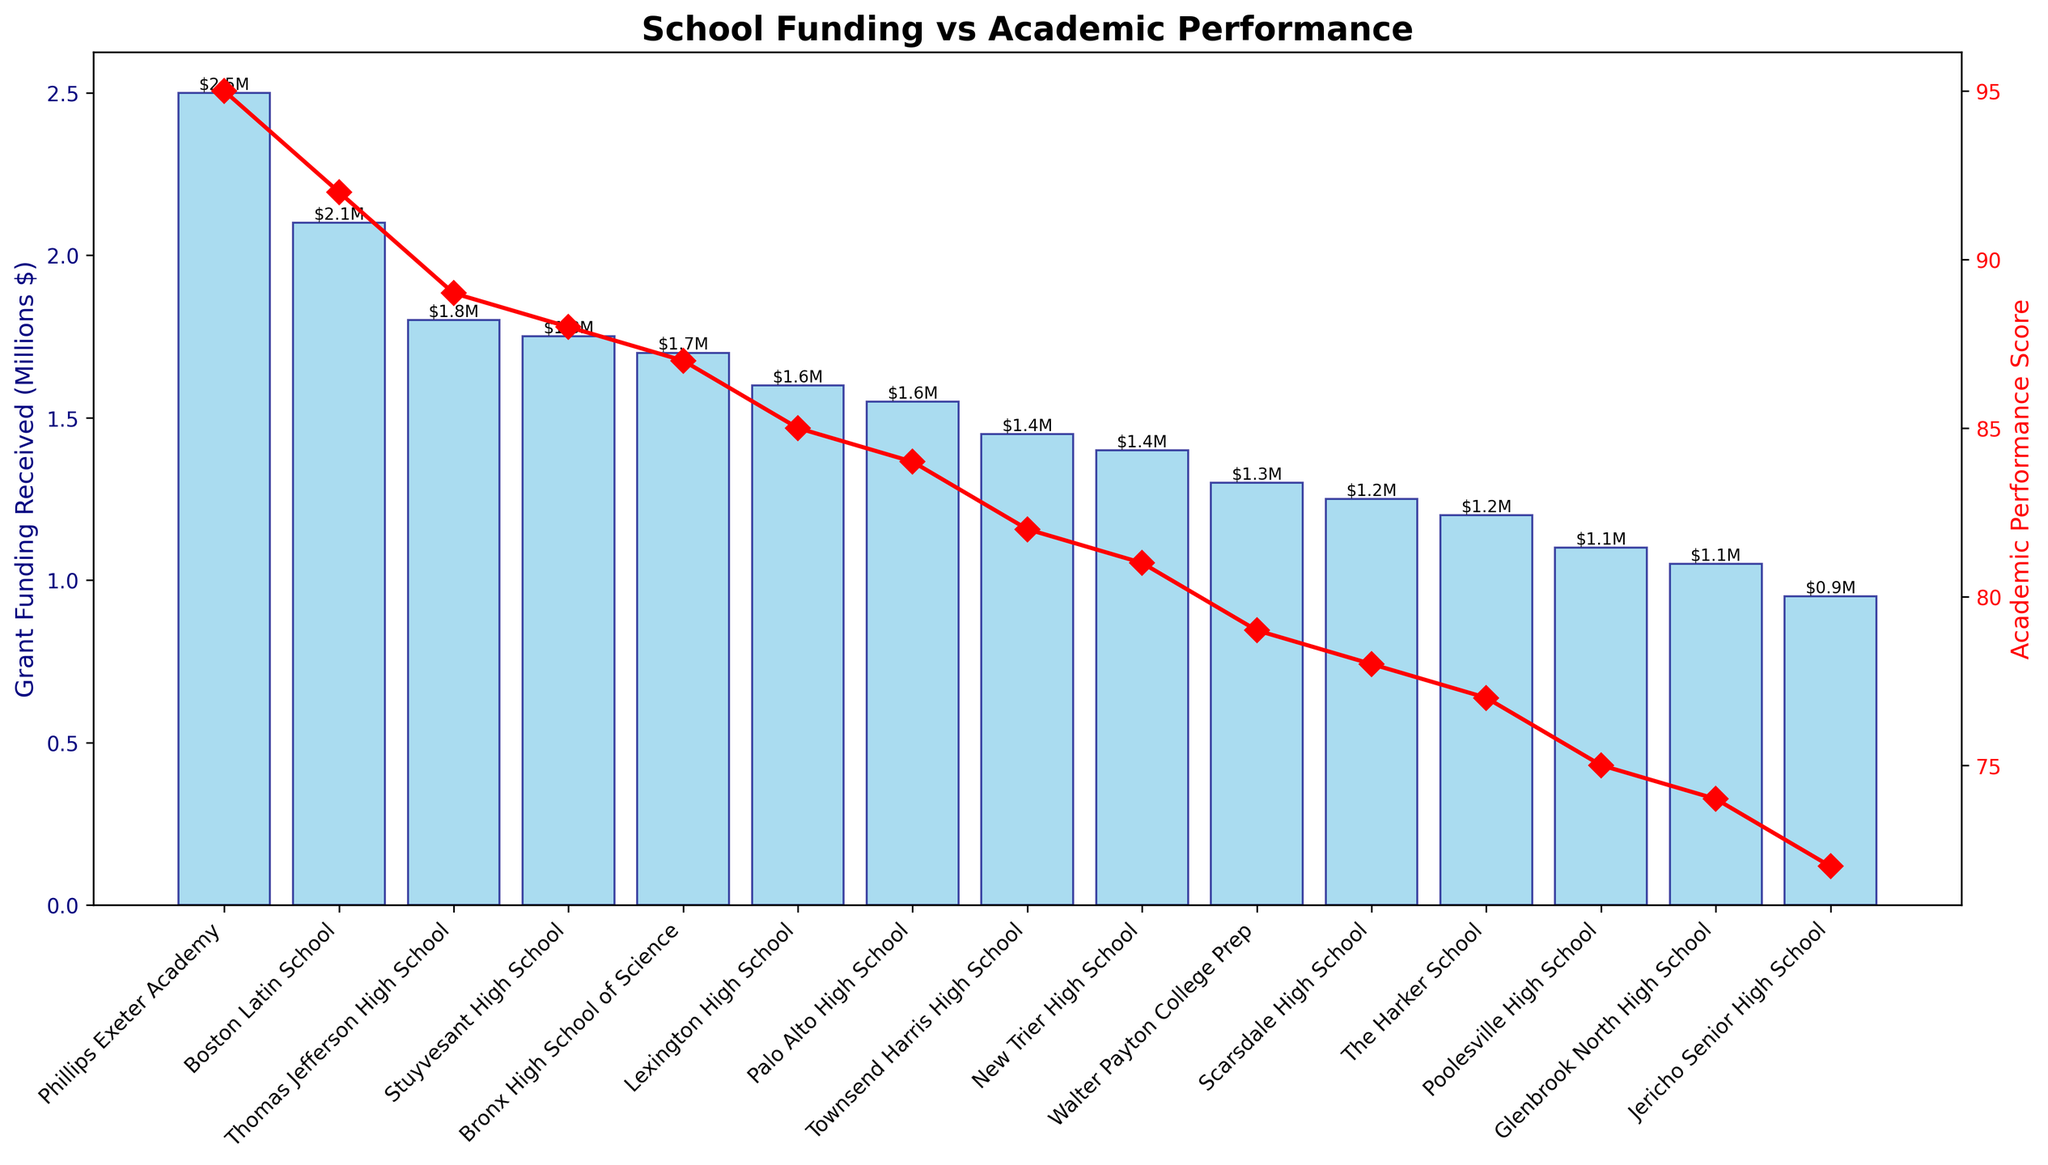what is the total grant funding received by the top three schools in terms of academic performance? To find the total grant funding for the top three schools, we sum the amounts received by Phillips Exeter Academy, Boston Latin School, and Thomas Jefferson High School. The grant funding received is $2,500,000, $2,100,000, and $1,800,000 respectively. Therefore, the total is $2,500,000 + $2,100,000 + $1,800,000 = $6,400,000.
Answer: $6,400,000 Which school has the highest academic performance score, and what is the amount of grant funding it received? The highest academic performance score is 95, which belongs to Phillips Exeter Academy. The grant funding received by Phillips Exeter Academy is $2,500,000.
Answer: Phillips Exeter Academy, $2,500,000 Which school received more grant funding: Lexington High School or The Harker School? Comparing the grant funding of both schools, Lexington High School received $1,600,000, and The Harker School received $1,200,000. Therefore, Lexington High School received more grant funding.
Answer: Lexington High School Which school has the lowest academic performance score, and what is the amount of grant funding it received? The lowest academic performance score is 72, which belongs to Jericho Senior High School. The grant funding received by Jericho Senior High School is $950,000.
Answer: Jericho Senior High School, $950,000 What is the difference in grant funding between the school with the highest academic performance score and the school with the lowest academic performance score? Phillips Exeter Academy has the highest academic performance score with a grant funding of $2,500,000, and Jericho Senior High School has the lowest score with $950,000. The difference is $2,500,000 - $950,000 = $1,550,000.
Answer: $1,550,000 What is the average amount of grant funding received by all schools? The total grant funding received by all schools is the sum of the individual amounts. Adding these amounts gives $21,350,000. Dividing this by 15 schools gives the average: $21,350,000 / 15 ≈ $1,423,333.33.
Answer: $1,423,333.33 Are there any schools that received the same amount of grant funding? By examining the bars on the chart, we see that no two schools received exactly the same amount of grant funding.
Answer: No What is the relationship between academic performance and grant funding for the top five schools? The top five schools based on academic performance scores are Phillips Exeter Academy, Boston Latin School, Thomas Jefferson High School, Stuyvesant High School, and Bronx High School of Science. As academic performance decreases, the grant funding also decreases. Specifically, it goes from $2,500,000 to $2,100,000 to $1,800,000 to $1,750,000 to $1,700,000.
Answer: Decreasing trend Which school has the highest funding per point of academic performance score, and what is the value? To find the highest funding per point, calculate the ratio for each school and compare. The best ratio can be observed by comparing individual ratios: Phillips Exeter Academy $2,500,000/95 ≈ $26,316. Boston Latin School $2,100,000/92 ≈ $22,826. The highest ratio is from Phillips Exeter Academy, with approximately $26,316 per point.
Answer: Phillips Exeter Academy, $26,316 